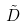<formula> <loc_0><loc_0><loc_500><loc_500>\tilde { D }</formula> 